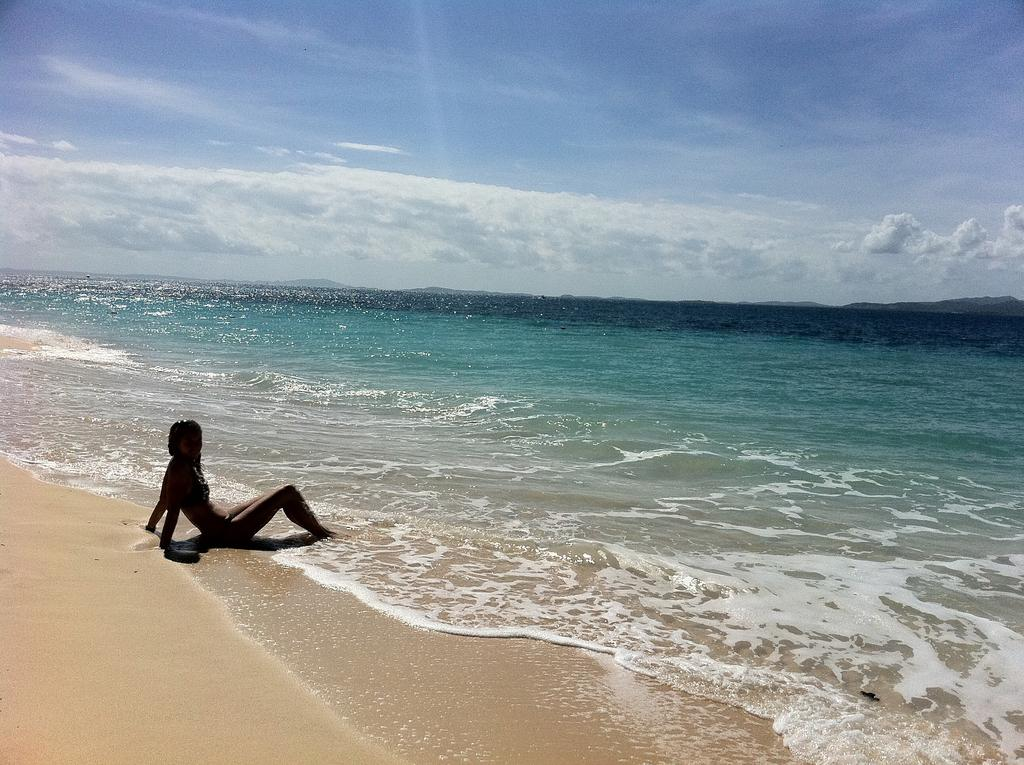What is the person in the image doing? The person is sitting on the ground in the image. What can be seen in the background of the image? There is water and the sky visible in the background of the image. What caption is written below the image? There is no caption present in the image; it is just a visual representation. 